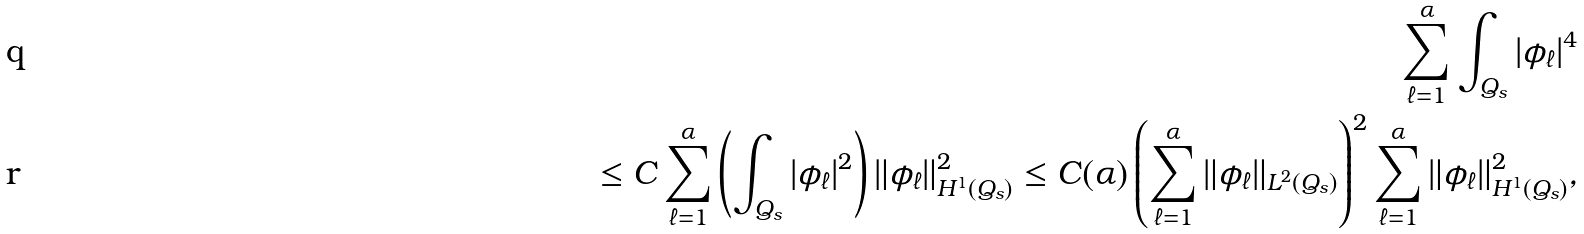Convert formula to latex. <formula><loc_0><loc_0><loc_500><loc_500>\sum _ { \ell = 1 } ^ { \alpha } \int _ { Q _ { s } } | \phi _ { \ell } | ^ { 4 } \\ \leq C \sum _ { \ell = 1 } ^ { \alpha } \left ( \int _ { Q _ { s } } | \phi _ { \ell } | ^ { 2 } \right ) \| \phi _ { \ell } \| ^ { 2 } _ { H ^ { 1 } ( Q _ { s } ) } \leq C ( \alpha ) \left ( \sum _ { \ell = 1 } ^ { \alpha } \| \phi _ { \ell } \| _ { L ^ { 2 } ( Q _ { s } ) } \right ) ^ { 2 } \sum _ { \ell = 1 } ^ { \alpha } \| \phi _ { \ell } \| ^ { 2 } _ { H ^ { 1 } ( Q _ { s } ) } , &</formula> 